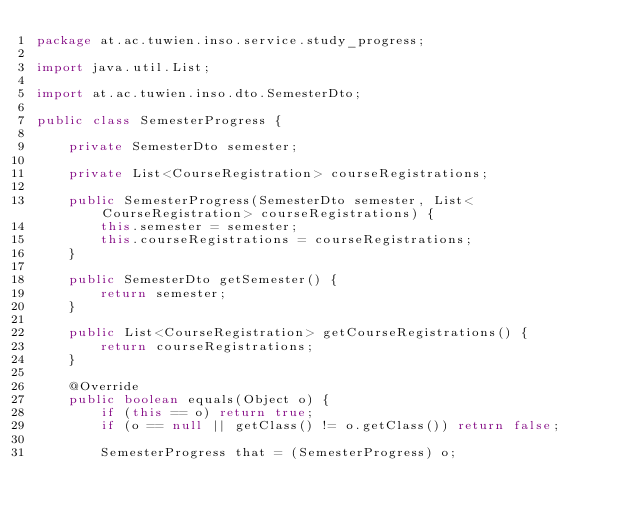<code> <loc_0><loc_0><loc_500><loc_500><_Java_>package at.ac.tuwien.inso.service.study_progress;

import java.util.List;

import at.ac.tuwien.inso.dto.SemesterDto;

public class SemesterProgress {

    private SemesterDto semester;

    private List<CourseRegistration> courseRegistrations;

    public SemesterProgress(SemesterDto semester, List<CourseRegistration> courseRegistrations) {
        this.semester = semester;
        this.courseRegistrations = courseRegistrations;
    }

    public SemesterDto getSemester() {
        return semester;
    }

    public List<CourseRegistration> getCourseRegistrations() {
        return courseRegistrations;
    }

    @Override
    public boolean equals(Object o) {
        if (this == o) return true;
        if (o == null || getClass() != o.getClass()) return false;

        SemesterProgress that = (SemesterProgress) o;
</code> 